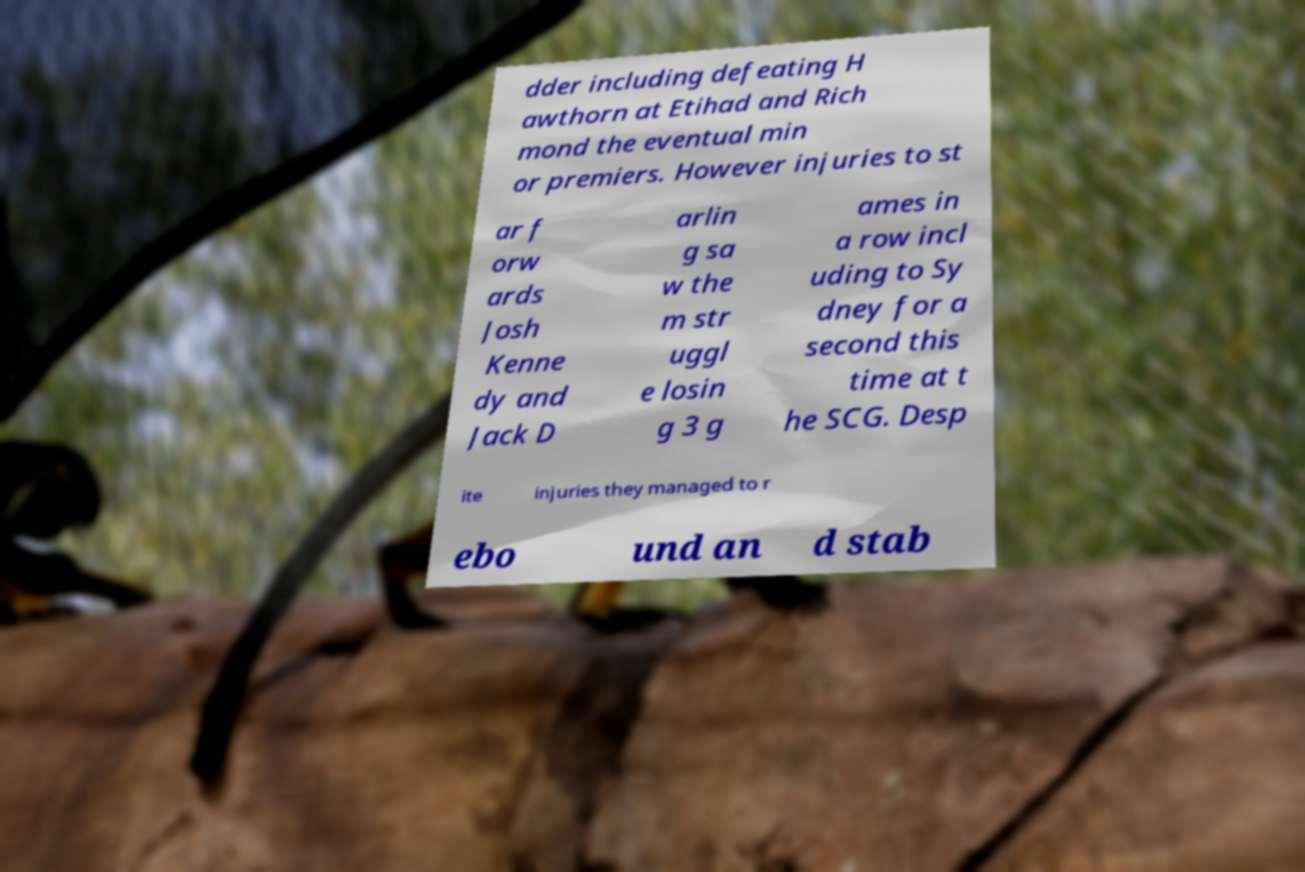What messages or text are displayed in this image? I need them in a readable, typed format. dder including defeating H awthorn at Etihad and Rich mond the eventual min or premiers. However injuries to st ar f orw ards Josh Kenne dy and Jack D arlin g sa w the m str uggl e losin g 3 g ames in a row incl uding to Sy dney for a second this time at t he SCG. Desp ite injuries they managed to r ebo und an d stab 